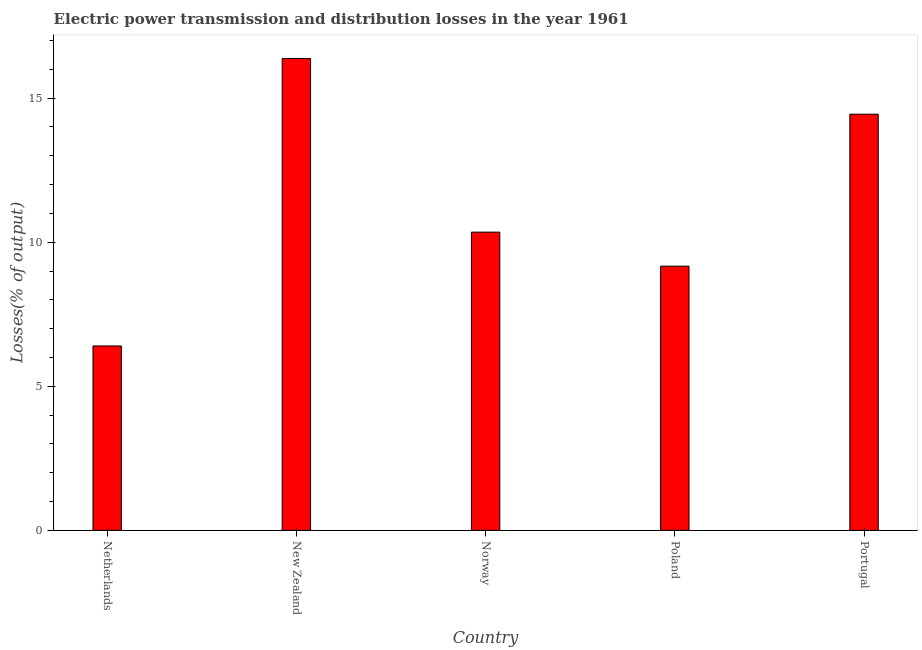What is the title of the graph?
Offer a terse response. Electric power transmission and distribution losses in the year 1961. What is the label or title of the X-axis?
Make the answer very short. Country. What is the label or title of the Y-axis?
Your answer should be very brief. Losses(% of output). What is the electric power transmission and distribution losses in Netherlands?
Offer a terse response. 6.4. Across all countries, what is the maximum electric power transmission and distribution losses?
Your answer should be very brief. 16.38. Across all countries, what is the minimum electric power transmission and distribution losses?
Your response must be concise. 6.4. In which country was the electric power transmission and distribution losses maximum?
Ensure brevity in your answer.  New Zealand. What is the sum of the electric power transmission and distribution losses?
Ensure brevity in your answer.  56.74. What is the difference between the electric power transmission and distribution losses in Norway and Poland?
Offer a very short reply. 1.18. What is the average electric power transmission and distribution losses per country?
Provide a succinct answer. 11.35. What is the median electric power transmission and distribution losses?
Offer a terse response. 10.35. In how many countries, is the electric power transmission and distribution losses greater than 13 %?
Make the answer very short. 2. What is the ratio of the electric power transmission and distribution losses in New Zealand to that in Poland?
Give a very brief answer. 1.79. Is the difference between the electric power transmission and distribution losses in Netherlands and New Zealand greater than the difference between any two countries?
Provide a short and direct response. Yes. What is the difference between the highest and the second highest electric power transmission and distribution losses?
Offer a terse response. 1.93. What is the difference between the highest and the lowest electric power transmission and distribution losses?
Offer a very short reply. 9.98. How many bars are there?
Provide a succinct answer. 5. Are all the bars in the graph horizontal?
Give a very brief answer. No. Are the values on the major ticks of Y-axis written in scientific E-notation?
Provide a succinct answer. No. What is the Losses(% of output) of Netherlands?
Keep it short and to the point. 6.4. What is the Losses(% of output) of New Zealand?
Your response must be concise. 16.38. What is the Losses(% of output) in Norway?
Provide a short and direct response. 10.35. What is the Losses(% of output) in Poland?
Offer a terse response. 9.17. What is the Losses(% of output) in Portugal?
Offer a very short reply. 14.44. What is the difference between the Losses(% of output) in Netherlands and New Zealand?
Give a very brief answer. -9.98. What is the difference between the Losses(% of output) in Netherlands and Norway?
Keep it short and to the point. -3.95. What is the difference between the Losses(% of output) in Netherlands and Poland?
Your answer should be compact. -2.77. What is the difference between the Losses(% of output) in Netherlands and Portugal?
Your response must be concise. -8.04. What is the difference between the Losses(% of output) in New Zealand and Norway?
Your response must be concise. 6.03. What is the difference between the Losses(% of output) in New Zealand and Poland?
Give a very brief answer. 7.21. What is the difference between the Losses(% of output) in New Zealand and Portugal?
Give a very brief answer. 1.93. What is the difference between the Losses(% of output) in Norway and Poland?
Your answer should be compact. 1.18. What is the difference between the Losses(% of output) in Norway and Portugal?
Keep it short and to the point. -4.09. What is the difference between the Losses(% of output) in Poland and Portugal?
Provide a short and direct response. -5.27. What is the ratio of the Losses(% of output) in Netherlands to that in New Zealand?
Your answer should be compact. 0.39. What is the ratio of the Losses(% of output) in Netherlands to that in Norway?
Provide a succinct answer. 0.62. What is the ratio of the Losses(% of output) in Netherlands to that in Poland?
Your answer should be very brief. 0.7. What is the ratio of the Losses(% of output) in Netherlands to that in Portugal?
Your answer should be very brief. 0.44. What is the ratio of the Losses(% of output) in New Zealand to that in Norway?
Keep it short and to the point. 1.58. What is the ratio of the Losses(% of output) in New Zealand to that in Poland?
Your response must be concise. 1.79. What is the ratio of the Losses(% of output) in New Zealand to that in Portugal?
Provide a succinct answer. 1.13. What is the ratio of the Losses(% of output) in Norway to that in Poland?
Ensure brevity in your answer.  1.13. What is the ratio of the Losses(% of output) in Norway to that in Portugal?
Your response must be concise. 0.72. What is the ratio of the Losses(% of output) in Poland to that in Portugal?
Offer a terse response. 0.64. 